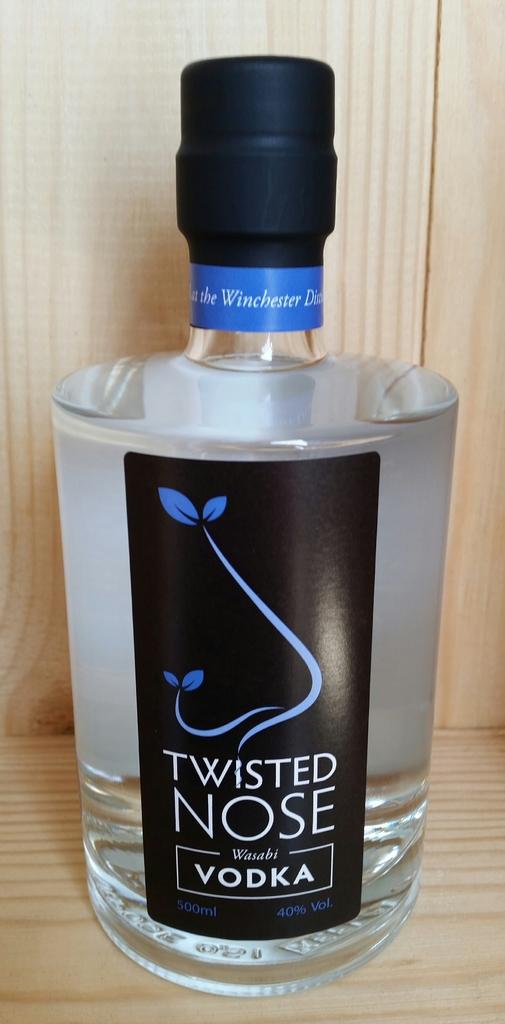Who makes this vodka?
Your answer should be compact. Twisted nose. Is this vodka at least 80 proof?
Provide a short and direct response. Yes. 